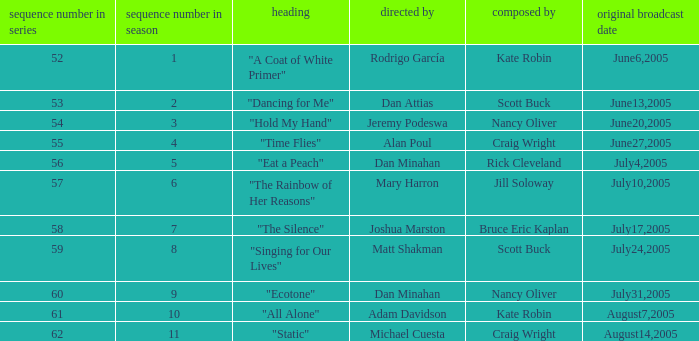What was the name of the episode that was directed by Mary Harron? "The Rainbow of Her Reasons". Could you parse the entire table? {'header': ['sequence number in series', 'sequence number in season', 'heading', 'directed by', 'composed by', 'original broadcast date'], 'rows': [['52', '1', '"A Coat of White Primer"', 'Rodrigo García', 'Kate Robin', 'June6,2005'], ['53', '2', '"Dancing for Me"', 'Dan Attias', 'Scott Buck', 'June13,2005'], ['54', '3', '"Hold My Hand"', 'Jeremy Podeswa', 'Nancy Oliver', 'June20,2005'], ['55', '4', '"Time Flies"', 'Alan Poul', 'Craig Wright', 'June27,2005'], ['56', '5', '"Eat a Peach"', 'Dan Minahan', 'Rick Cleveland', 'July4,2005'], ['57', '6', '"The Rainbow of Her Reasons"', 'Mary Harron', 'Jill Soloway', 'July10,2005'], ['58', '7', '"The Silence"', 'Joshua Marston', 'Bruce Eric Kaplan', 'July17,2005'], ['59', '8', '"Singing for Our Lives"', 'Matt Shakman', 'Scott Buck', 'July24,2005'], ['60', '9', '"Ecotone"', 'Dan Minahan', 'Nancy Oliver', 'July31,2005'], ['61', '10', '"All Alone"', 'Adam Davidson', 'Kate Robin', 'August7,2005'], ['62', '11', '"Static"', 'Michael Cuesta', 'Craig Wright', 'August14,2005']]} 